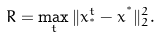Convert formula to latex. <formula><loc_0><loc_0><loc_500><loc_500>R = \max _ { t } \| x _ { ^ { * } } ^ { t } - x ^ { ^ { * } } \| _ { 2 } ^ { 2 } .</formula> 